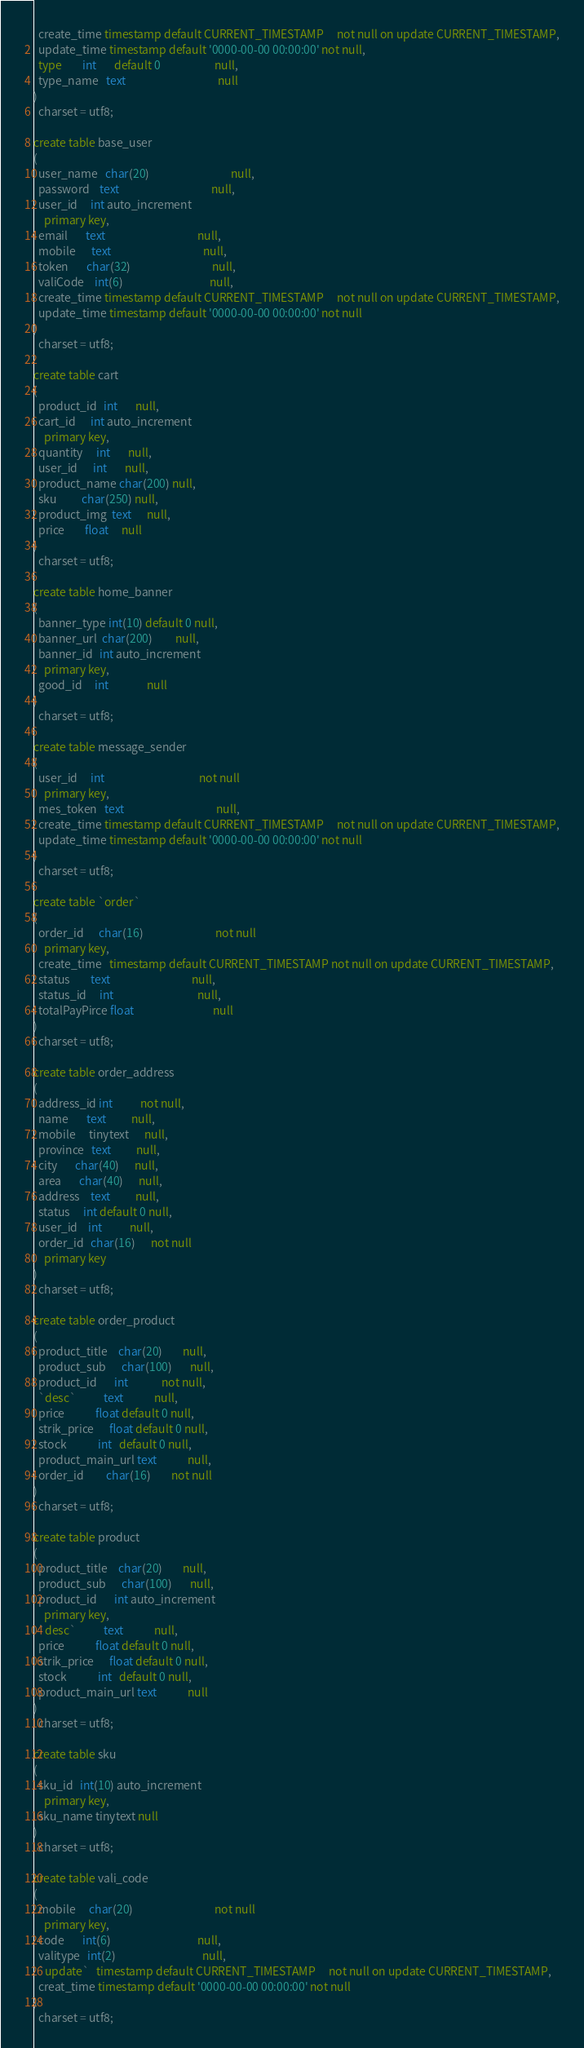<code> <loc_0><loc_0><loc_500><loc_500><_SQL_>  create_time timestamp default CURRENT_TIMESTAMP     not null on update CURRENT_TIMESTAMP,
  update_time timestamp default '0000-00-00 00:00:00' not null,
  type        int       default 0                     null,
  type_name   text                                    null
)
  charset = utf8;

create table base_user
(
  user_name   char(20)                                null,
  password    text                                    null,
  user_id     int auto_increment
    primary key,
  email       text                                    null,
  mobile      text                                    null,
  token       char(32)                                null,
  valiCode    int(6)                                  null,
  create_time timestamp default CURRENT_TIMESTAMP     not null on update CURRENT_TIMESTAMP,
  update_time timestamp default '0000-00-00 00:00:00' not null
)
  charset = utf8;

create table cart
(
  product_id   int       null,
  cart_id      int auto_increment
    primary key,
  quantity     int       null,
  user_id      int       null,
  product_name char(200) null,
  sku          char(250) null,
  product_img  text      null,
  price        float     null
)
  charset = utf8;

create table home_banner
(
  banner_type int(10) default 0 null,
  banner_url  char(200)         null,
  banner_id   int auto_increment
    primary key,
  good_id     int               null
)
  charset = utf8;

create table message_sender
(
  user_id     int                                     not null
    primary key,
  mes_token   text                                    null,
  create_time timestamp default CURRENT_TIMESTAMP     not null on update CURRENT_TIMESTAMP,
  update_time timestamp default '0000-00-00 00:00:00' not null
)
  charset = utf8;

create table `order`
(
  order_id      char(16)                            not null
    primary key,
  create_time   timestamp default CURRENT_TIMESTAMP not null on update CURRENT_TIMESTAMP,
  status        text                                null,
  status_id     int                                 null,
  totalPayPirce float                               null
)
  charset = utf8;

create table order_address
(
  address_id int           not null,
  name       text          null,
  mobile     tinytext      null,
  province   text          null,
  city       char(40)      null,
  area       char(40)      null,
  address    text          null,
  status     int default 0 null,
  user_id    int           null,
  order_id   char(16)      not null
    primary key
)
  charset = utf8;

create table order_product
(
  product_title    char(20)        null,
  product_sub      char(100)       null,
  product_id       int             not null,
  `desc`           text            null,
  price            float default 0 null,
  strik_price      float default 0 null,
  stock            int   default 0 null,
  product_main_url text            null,
  order_id         char(16)        not null
)
  charset = utf8;

create table product
(
  product_title    char(20)        null,
  product_sub      char(100)       null,
  product_id       int auto_increment
    primary key,
  `desc`           text            null,
  price            float default 0 null,
  strik_price      float default 0 null,
  stock            int   default 0 null,
  product_main_url text            null
)
  charset = utf8;

create table sku
(
  sku_id   int(10) auto_increment
    primary key,
  sku_name tinytext null
)
  charset = utf8;

create table vali_code
(
  mobile     char(20)                                not null
    primary key,
  code       int(6)                                  null,
  valitype   int(2)                                  null,
  `update`   timestamp default CURRENT_TIMESTAMP     not null on update CURRENT_TIMESTAMP,
  creat_time timestamp default '0000-00-00 00:00:00' not null
)
  charset = utf8;
</code> 